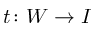Convert formula to latex. <formula><loc_0><loc_0><loc_500><loc_500>t \colon W \to I</formula> 